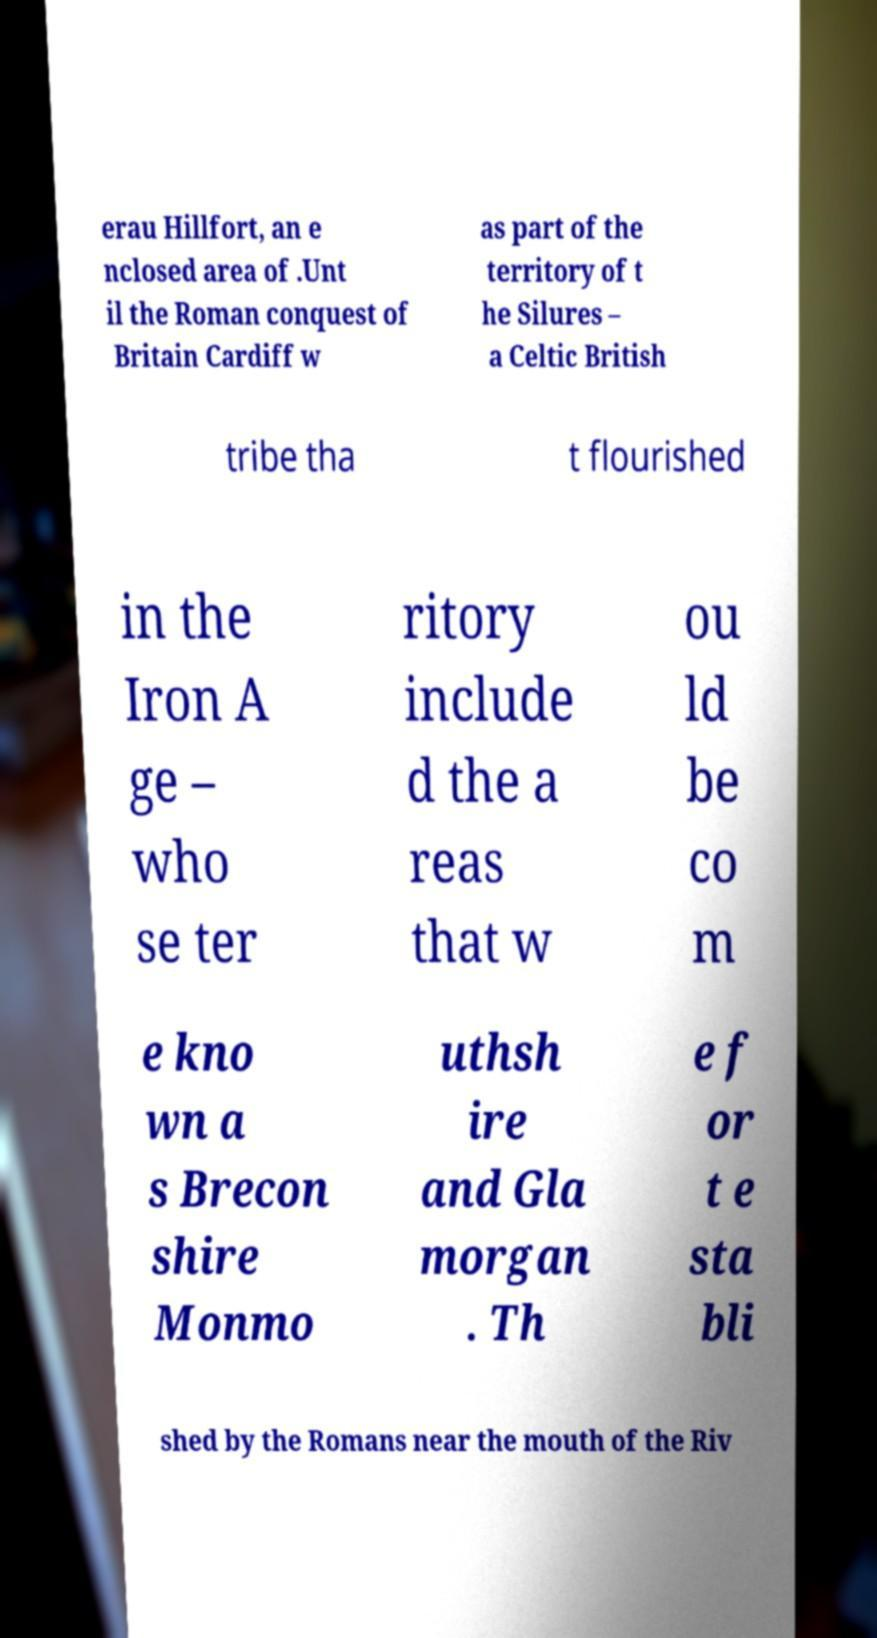There's text embedded in this image that I need extracted. Can you transcribe it verbatim? erau Hillfort, an e nclosed area of .Unt il the Roman conquest of Britain Cardiff w as part of the territory of t he Silures – a Celtic British tribe tha t flourished in the Iron A ge – who se ter ritory include d the a reas that w ou ld be co m e kno wn a s Brecon shire Monmo uthsh ire and Gla morgan . Th e f or t e sta bli shed by the Romans near the mouth of the Riv 